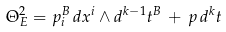<formula> <loc_0><loc_0><loc_500><loc_500>\Theta ^ { 2 } _ { E } = p ^ { B } _ { i } \, d x ^ { i } \wedge d ^ { k - 1 } t ^ { B } \, + \, p \, d ^ { k } t</formula> 